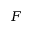Convert formula to latex. <formula><loc_0><loc_0><loc_500><loc_500>F</formula> 